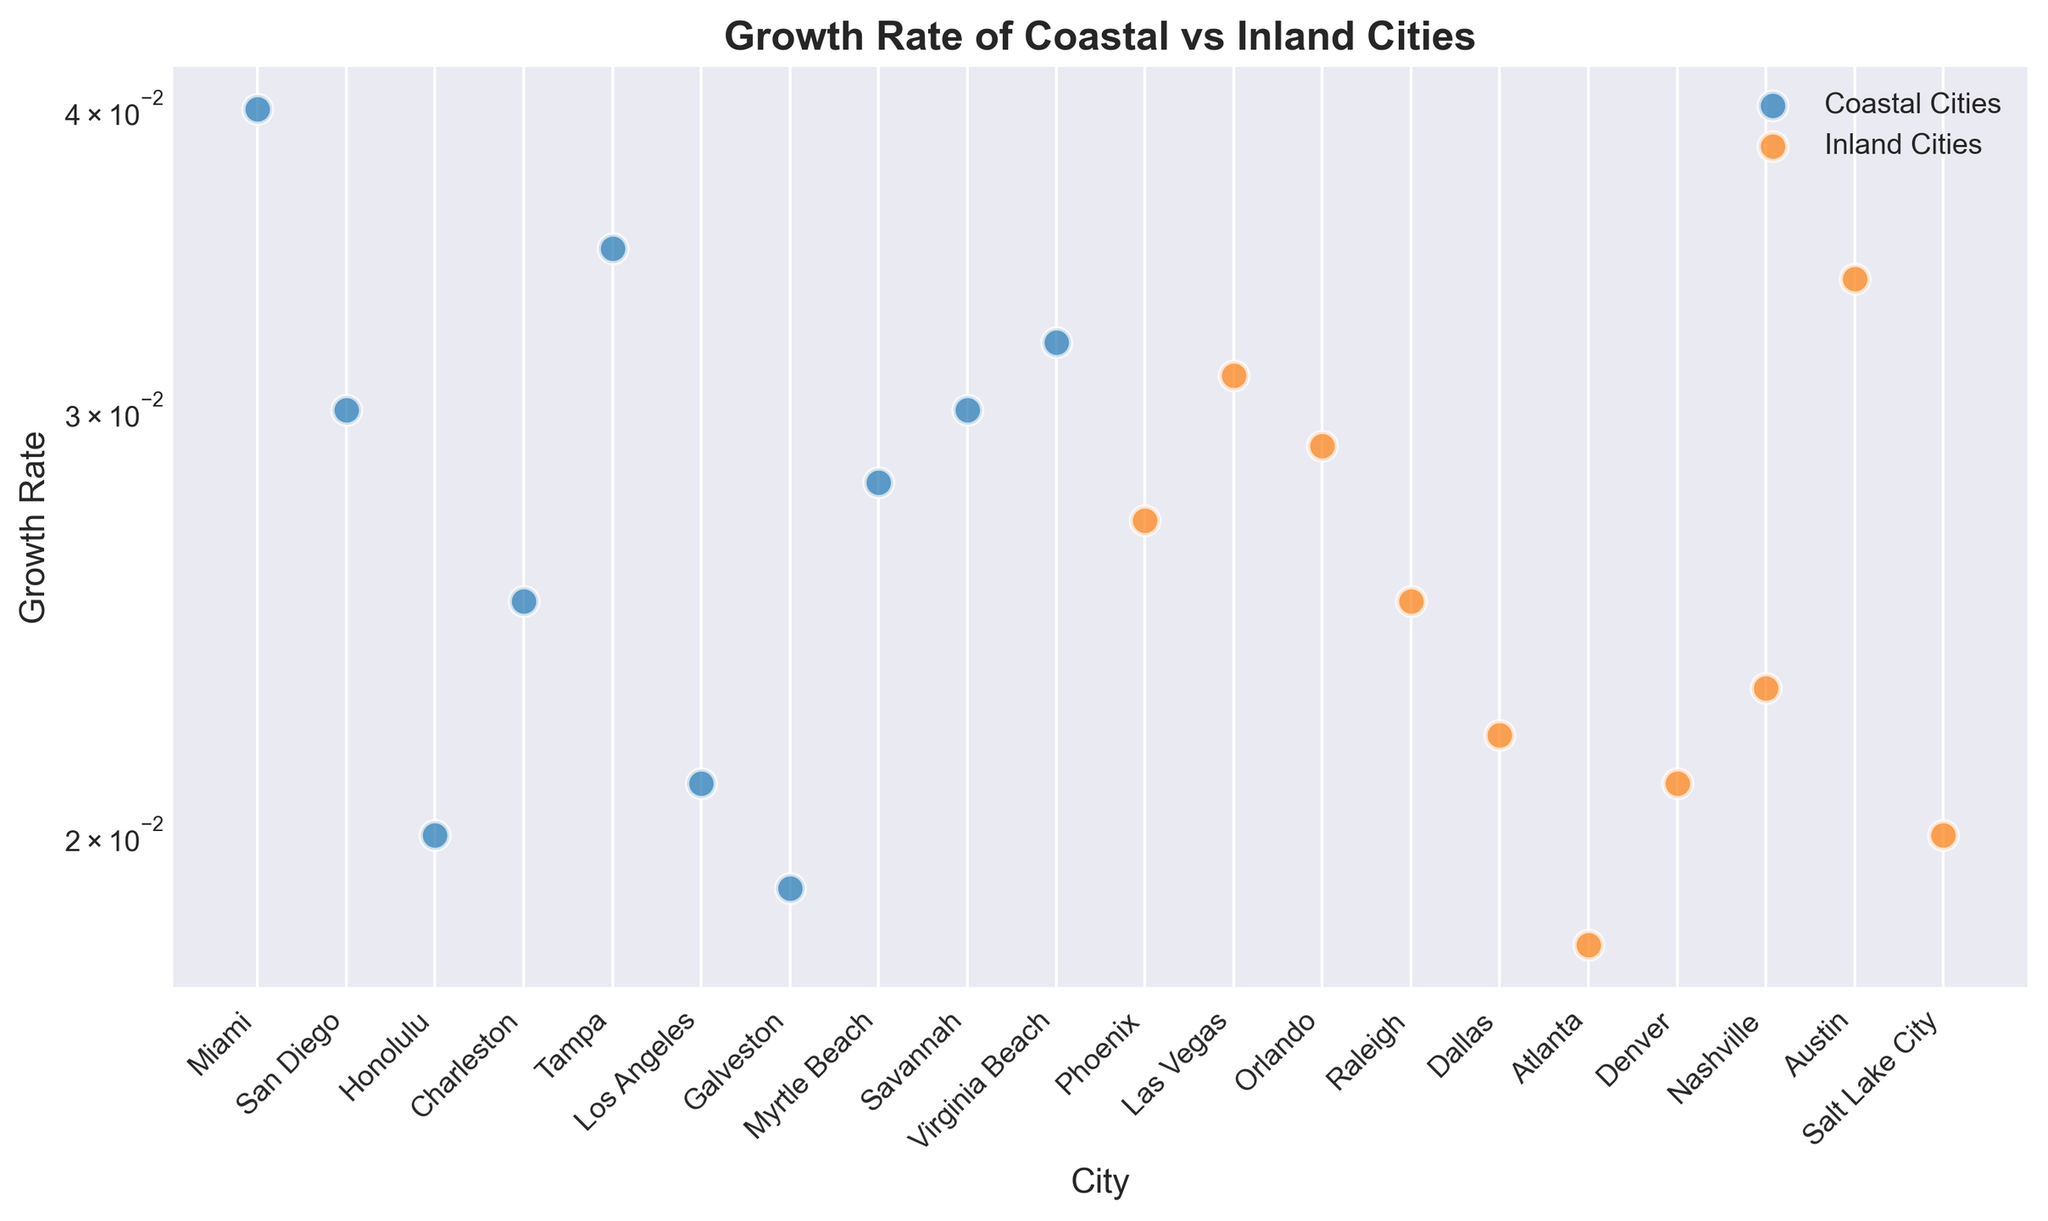What's the city with the highest growth rate among coastal cities? From the chart, the data points for coastal cities can be directly compared. The city with the highest growth rate among the coastal cities is Tampa.
Answer: Tampa Compare the growth rates of the coastal city with the highest growth rate and the inland city with the highest growth rate. Which one is higher? From the chart, Tampa has the highest growth rate among coastal cities (0.035), and Austin has the highest growth rate among inland cities (0.034). Comparing these, Tampa's growth rate is higher than Austin's.
Answer: Tampa What is the average growth rate of the coastal cities? To find the average growth rate of the coastal cities, add the growth rates of all coastal cities and divide by the number of coastal cities: (0.04 + 0.03 + 0.02 + 0.025 + 0.035 + 0.021 + 0.019 + 0.028 + 0.03 + 0.032) / 10 = 0.028.
Answer: 0.028 How does the median growth rate of coastal cities compare to that of inland cities? To find the median growth rate, first, list the growth rates in ascending order. For coastal cities: [0.019, 0.02, 0.021, 0.025, 0.028, 0.03, 0.03, 0.032, 0.035, 0.04], the median is (0.028 + 0.03) / 2 = 0.029. For inland cities: [0.018, 0.02, 0.021, 0.022, 0.023, 0.025, 0.027, 0.029, 0.031, 0.034], the median is (0.023 + 0.025) / 2 = 0.024. Comparing these, the coastal cities have a higher median growth rate than the inland cities.
Answer: Coastal cities have a higher median growth rate What is the difference in growth rate between the coastal city with the lowest growth rate and the inland city with the lowest growth rate? From the chart, the coastal city with the lowest growth rate is Galveston (0.019), and the inland city with the lowest growth rate is Atlanta (0.018). The difference is 0.019 - 0.018 = 0.001.
Answer: 0.001 Identify the coastal city and the inland city with the closest growth rates. What are these growth rates? From the chart, Las Vegas (inland, 0.031) and Virginia Beach (coastal, 0.032) have very close growth rates.
Answer: Las Vegas (0.031) and Virginia Beach (0.032) How many coastal cities have a growth rate greater than 0.03? From the chart, the coastal cities with growth rates greater than 0.03 are Miami, Tampa, and Virginia Beach. There are 3 such cities.
Answer: 3 Compare the average growth rate of coastal cities to that of inland cities. Which type has a higher average growth rate? The average growth rate of coastal cities is 0.028 (as calculated previously). To find the average for inland cities, add the growth rates of all inland cities and divide by the number of inland cities: (0.027 + 0.031 + 0.029 + 0.025 + 0.022 + 0.018 + 0.021 + 0.023 + 0.034 + 0.02) / 10 = 0.025. Comparing these, coastal cities have a higher average growth rate than inland cities.
Answer: Coastal cities Which city has the highest growth rate overall? From the chart, the city with the highest growth rate overall is Miami (0.04).
Answer: Miami 